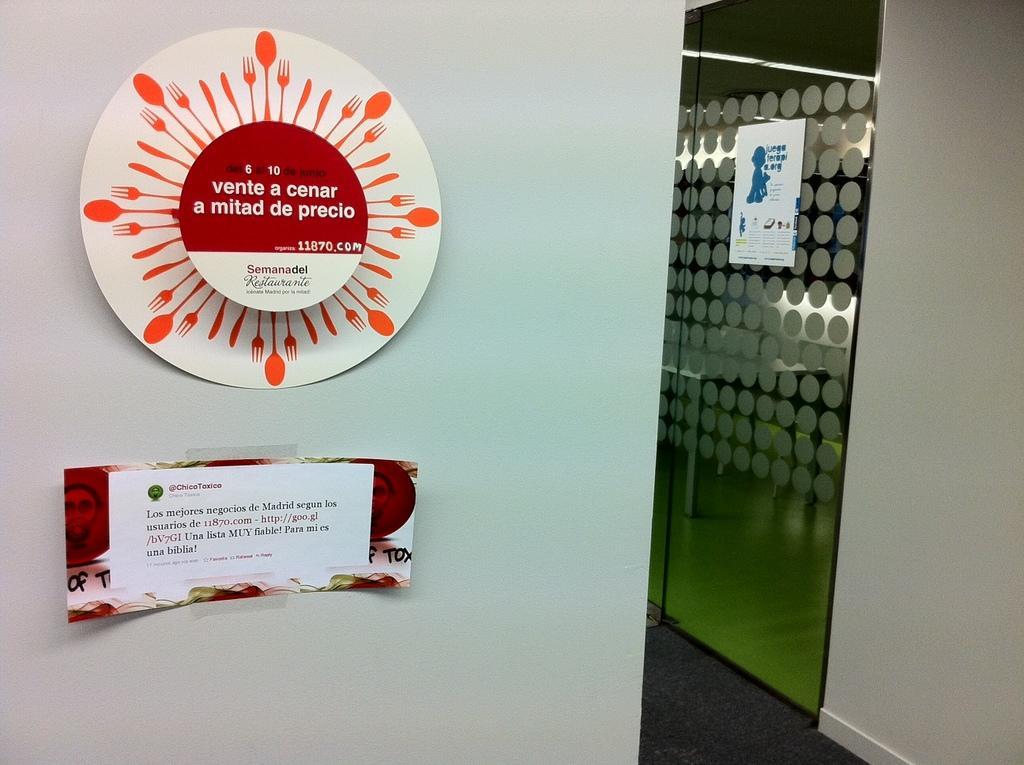In one or two sentences, can you explain what this image depicts? In this picture we can observe a white color wall to which two papers were stuck. On the right side there is a glass door on which we can observe a white color paper. 